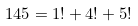<formula> <loc_0><loc_0><loc_500><loc_500>1 4 5 = 1 ! + 4 ! + 5 !</formula> 